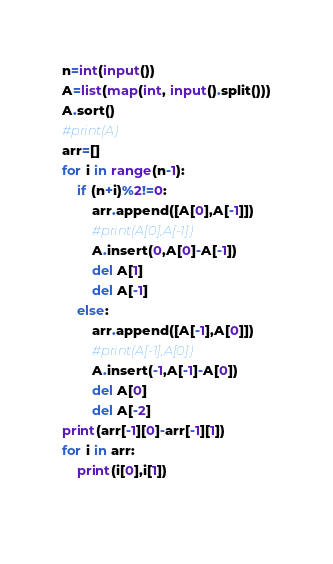<code> <loc_0><loc_0><loc_500><loc_500><_Python_>n=int(input())
A=list(map(int, input().split()))
A.sort()
#print(A)
arr=[]
for i in range(n-1):
    if (n+i)%2!=0:
        arr.append([A[0],A[-1]])
        #print(A[0],A[-1])
        A.insert(0,A[0]-A[-1])
        del A[1]
        del A[-1]
    else:
        arr.append([A[-1],A[0]])
        #print(A[-1],A[0])
        A.insert(-1,A[-1]-A[0])
        del A[0]
        del A[-2]
print(arr[-1][0]-arr[-1][1])
for i in arr:
    print(i[0],i[1])
        </code> 